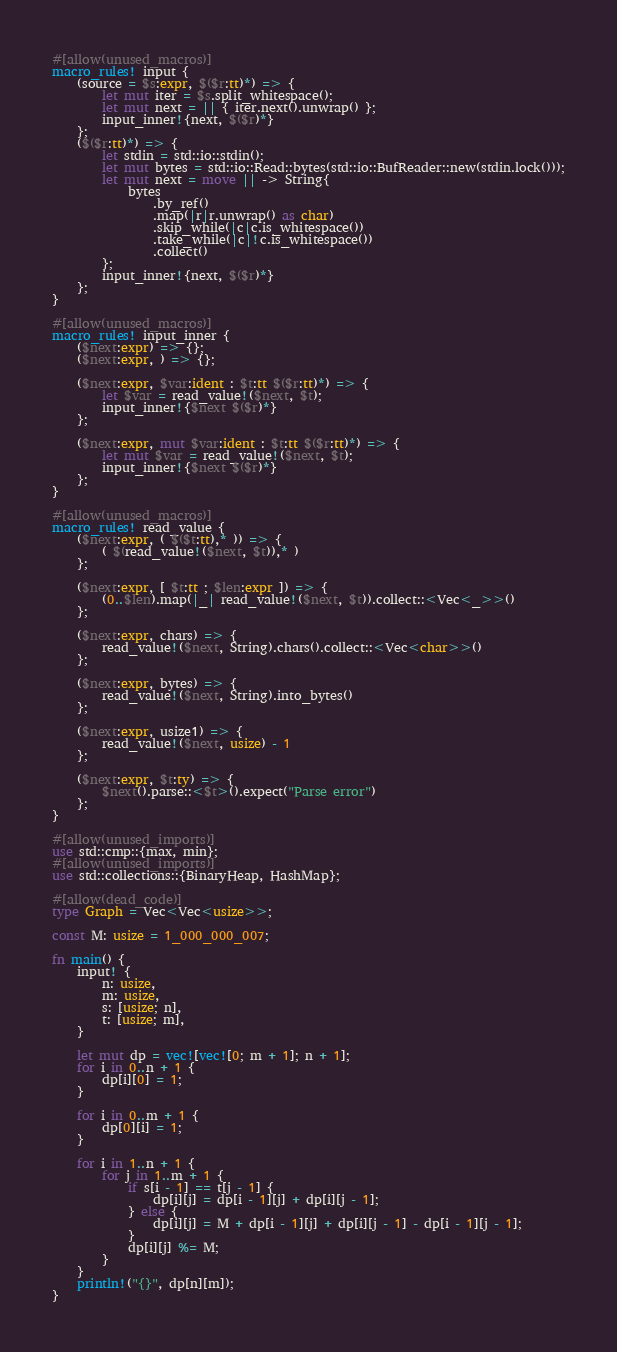Convert code to text. <code><loc_0><loc_0><loc_500><loc_500><_Rust_>#[allow(unused_macros)]
macro_rules! input {
    (source = $s:expr, $($r:tt)*) => {
        let mut iter = $s.split_whitespace();
        let mut next = || { iter.next().unwrap() };
        input_inner!{next, $($r)*}
    };
    ($($r:tt)*) => {
        let stdin = std::io::stdin();
        let mut bytes = std::io::Read::bytes(std::io::BufReader::new(stdin.lock()));
        let mut next = move || -> String{
            bytes
                .by_ref()
                .map(|r|r.unwrap() as char)
                .skip_while(|c|c.is_whitespace())
                .take_while(|c|!c.is_whitespace())
                .collect()
        };
        input_inner!{next, $($r)*}
    };
}

#[allow(unused_macros)]
macro_rules! input_inner {
    ($next:expr) => {};
    ($next:expr, ) => {};

    ($next:expr, $var:ident : $t:tt $($r:tt)*) => {
        let $var = read_value!($next, $t);
        input_inner!{$next $($r)*}
    };

    ($next:expr, mut $var:ident : $t:tt $($r:tt)*) => {
        let mut $var = read_value!($next, $t);
        input_inner!{$next $($r)*}
    };
}

#[allow(unused_macros)]
macro_rules! read_value {
    ($next:expr, ( $($t:tt),* )) => {
        ( $(read_value!($next, $t)),* )
    };

    ($next:expr, [ $t:tt ; $len:expr ]) => {
        (0..$len).map(|_| read_value!($next, $t)).collect::<Vec<_>>()
    };

    ($next:expr, chars) => {
        read_value!($next, String).chars().collect::<Vec<char>>()
    };

    ($next:expr, bytes) => {
        read_value!($next, String).into_bytes()
    };

    ($next:expr, usize1) => {
        read_value!($next, usize) - 1
    };

    ($next:expr, $t:ty) => {
        $next().parse::<$t>().expect("Parse error")
    };
}

#[allow(unused_imports)]
use std::cmp::{max, min};
#[allow(unused_imports)]
use std::collections::{BinaryHeap, HashMap};

#[allow(dead_code)]
type Graph = Vec<Vec<usize>>;

const M: usize = 1_000_000_007;

fn main() {
    input! {
        n: usize,
        m: usize,
        s: [usize; n],
        t: [usize; m],
    }

    let mut dp = vec![vec![0; m + 1]; n + 1];
    for i in 0..n + 1 {
        dp[i][0] = 1;
    }

    for i in 0..m + 1 {
        dp[0][i] = 1;
    }

    for i in 1..n + 1 {
        for j in 1..m + 1 {
            if s[i - 1] == t[j - 1] {
                dp[i][j] = dp[i - 1][j] + dp[i][j - 1];
            } else {
                dp[i][j] = M + dp[i - 1][j] + dp[i][j - 1] - dp[i - 1][j - 1];
            }
            dp[i][j] %= M;
        }
    }
    println!("{}", dp[n][m]);
}
</code> 